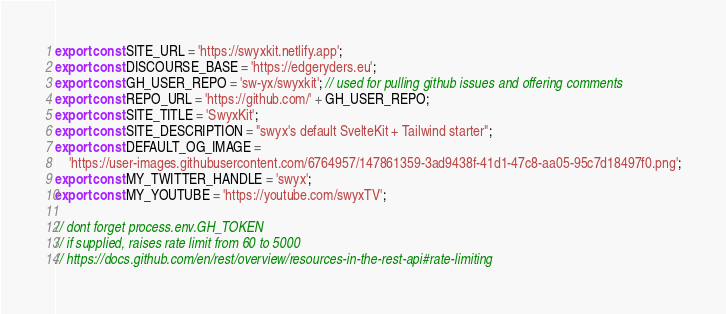Convert code to text. <code><loc_0><loc_0><loc_500><loc_500><_JavaScript_>export const SITE_URL = 'https://swyxkit.netlify.app';
export const DISCOURSE_BASE = 'https://edgeryders.eu';
export const GH_USER_REPO = 'sw-yx/swyxkit'; // used for pulling github issues and offering comments
export const REPO_URL = 'https://github.com/' + GH_USER_REPO;
export const SITE_TITLE = 'SwyxKit';
export const SITE_DESCRIPTION = "swyx's default SvelteKit + Tailwind starter";
export const DEFAULT_OG_IMAGE =
	'https://user-images.githubusercontent.com/6764957/147861359-3ad9438f-41d1-47c8-aa05-95c7d18497f0.png';
export const MY_TWITTER_HANDLE = 'swyx';
export const MY_YOUTUBE = 'https://youtube.com/swyxTV';

// dont forget process.env.GH_TOKEN
// if supplied, raises rate limit from 60 to 5000
// https://docs.github.com/en/rest/overview/resources-in-the-rest-api#rate-limiting
</code> 